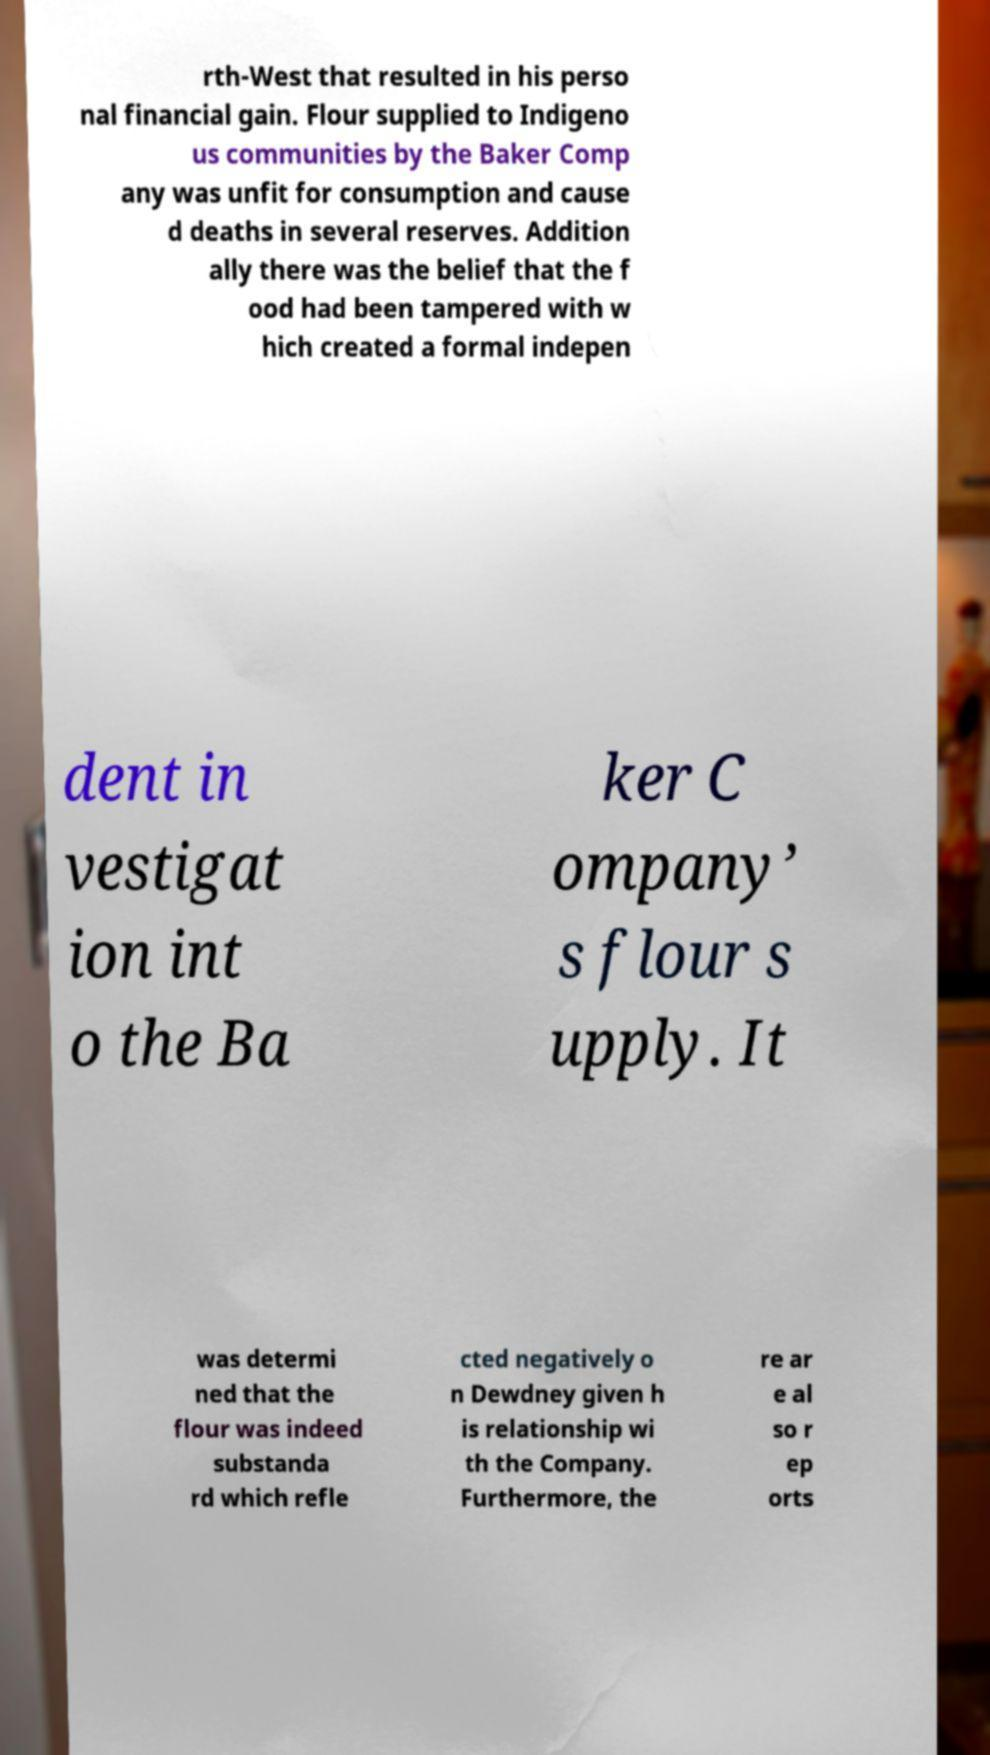Can you accurately transcribe the text from the provided image for me? rth-West that resulted in his perso nal financial gain. Flour supplied to Indigeno us communities by the Baker Comp any was unfit for consumption and cause d deaths in several reserves. Addition ally there was the belief that the f ood had been tampered with w hich created a formal indepen dent in vestigat ion int o the Ba ker C ompany’ s flour s upply. It was determi ned that the flour was indeed substanda rd which refle cted negatively o n Dewdney given h is relationship wi th the Company. Furthermore, the re ar e al so r ep orts 